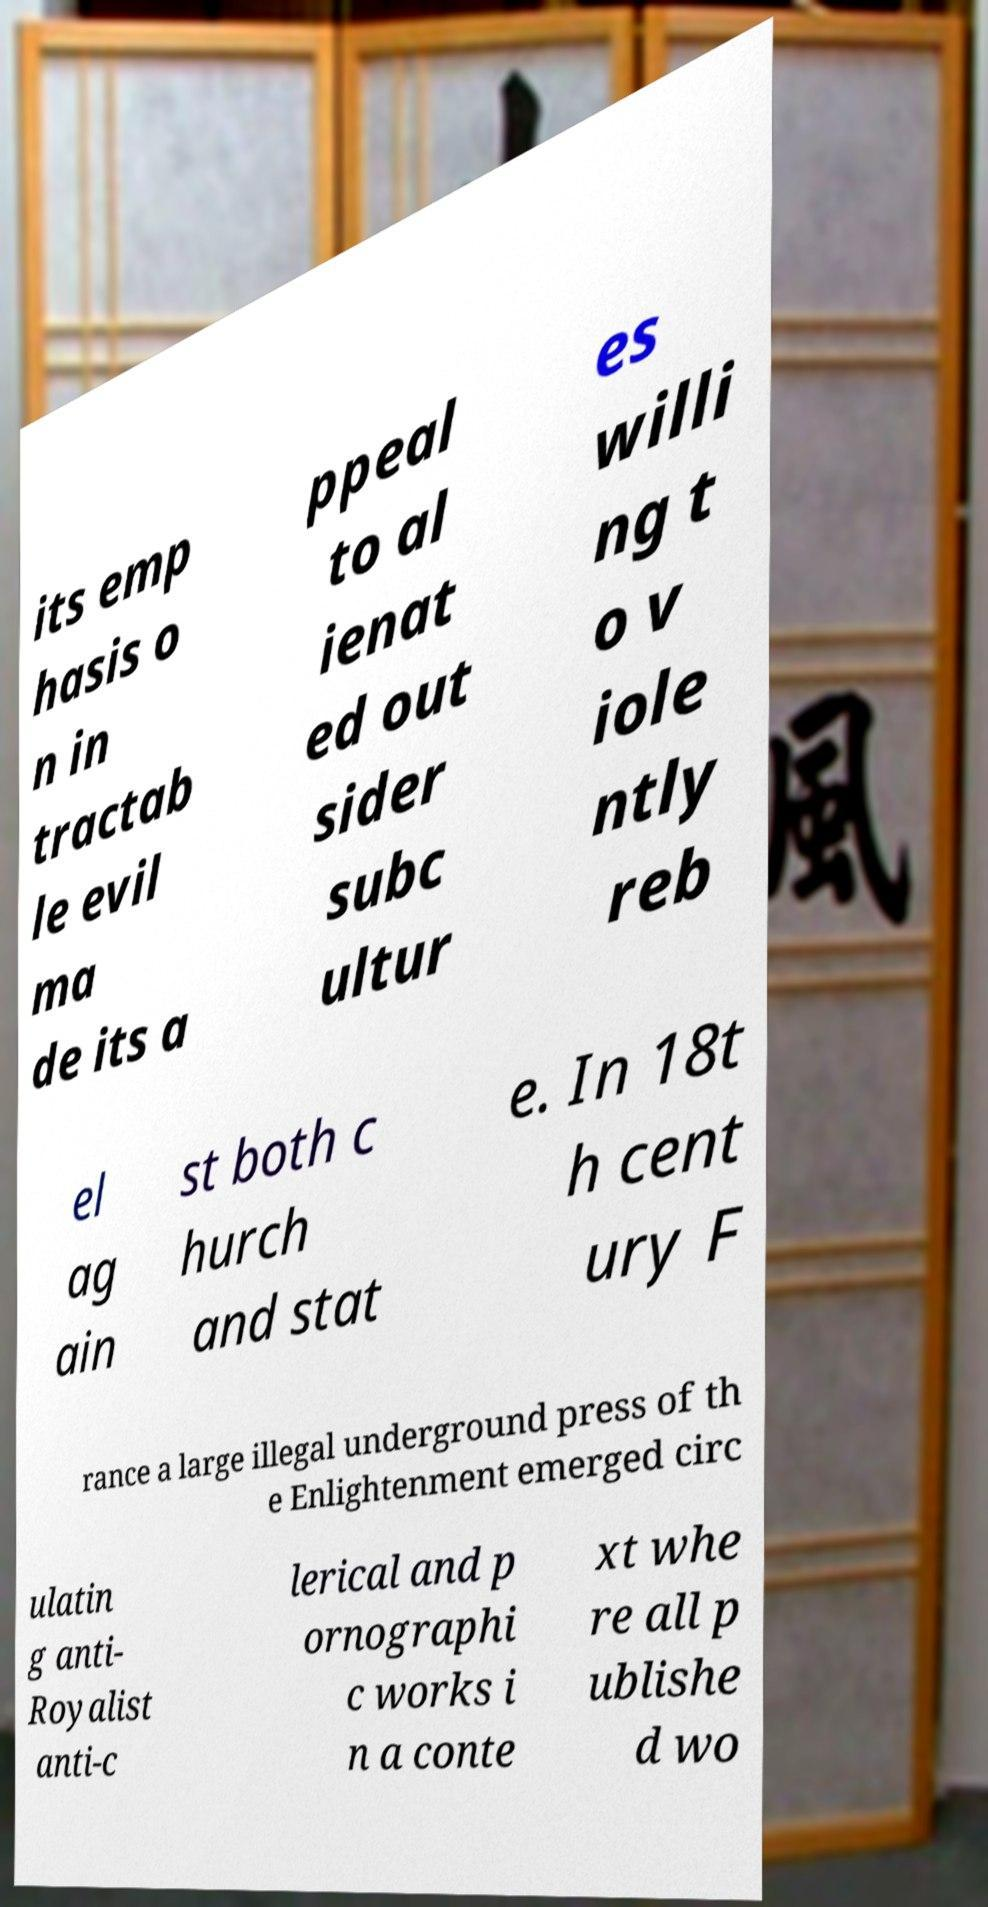There's text embedded in this image that I need extracted. Can you transcribe it verbatim? its emp hasis o n in tractab le evil ma de its a ppeal to al ienat ed out sider subc ultur es willi ng t o v iole ntly reb el ag ain st both c hurch and stat e. In 18t h cent ury F rance a large illegal underground press of th e Enlightenment emerged circ ulatin g anti- Royalist anti-c lerical and p ornographi c works i n a conte xt whe re all p ublishe d wo 